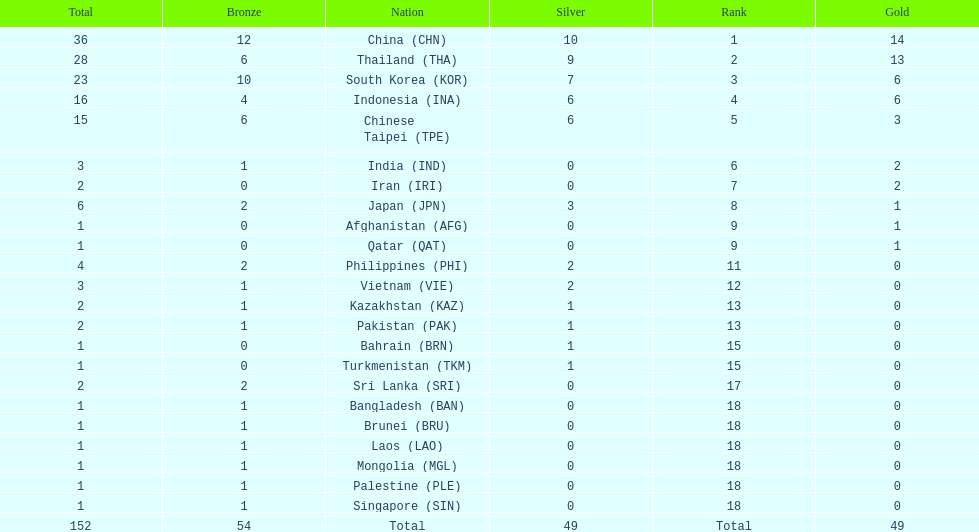Did the philippines or kazakhstan have a higher number of total medals? Philippines. 